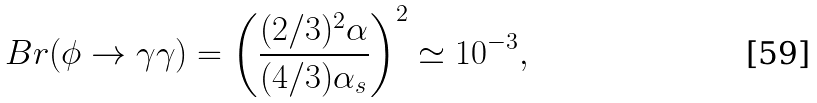Convert formula to latex. <formula><loc_0><loc_0><loc_500><loc_500>B r ( \phi \rightarrow \gamma \gamma ) = \left ( \frac { ( 2 / 3 ) ^ { 2 } \alpha } { ( 4 / 3 ) \alpha _ { s } } \right ) ^ { 2 } \simeq 1 0 ^ { - 3 } ,</formula> 